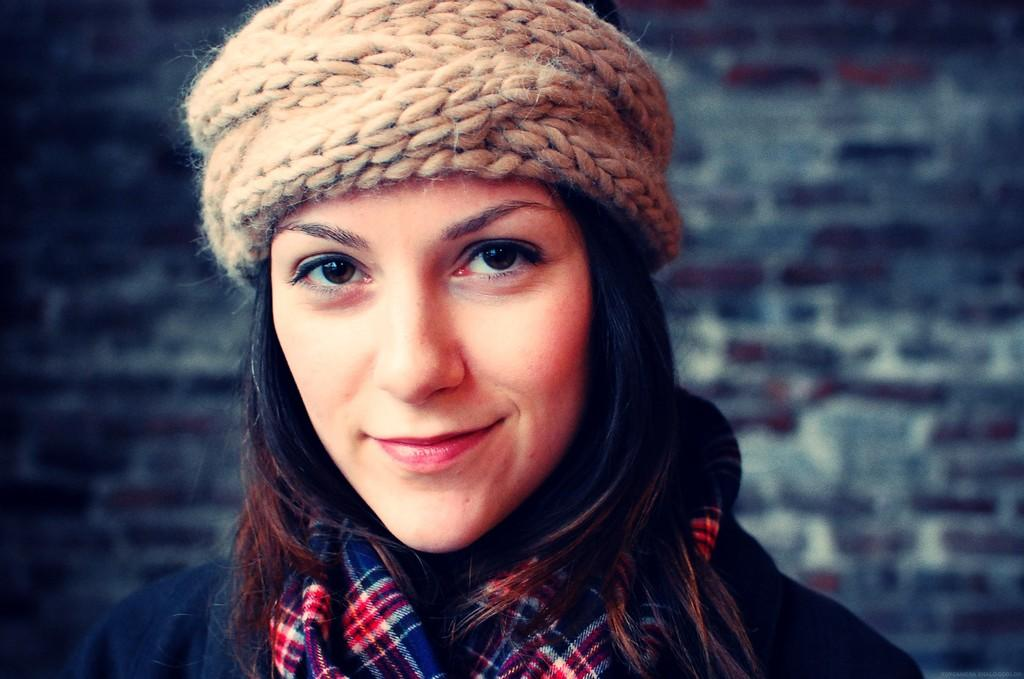What is the main subject of the image? The main subject of the image is a woman. What is the woman wearing in the image? The woman is wearing a dress and a hat in the image. What can be seen in the background of the image? There is a wall in the background of the image. Can you tell me how many monkeys are sitting on the wall in the image? There are no monkeys present in the image; it features a woman wearing a dress and a hat with a wall in the background. What type of material is the lead used for in the image? There is no mention of lead or any material in the image; it only features a woman wearing a dress and a hat with a wall in the background. 